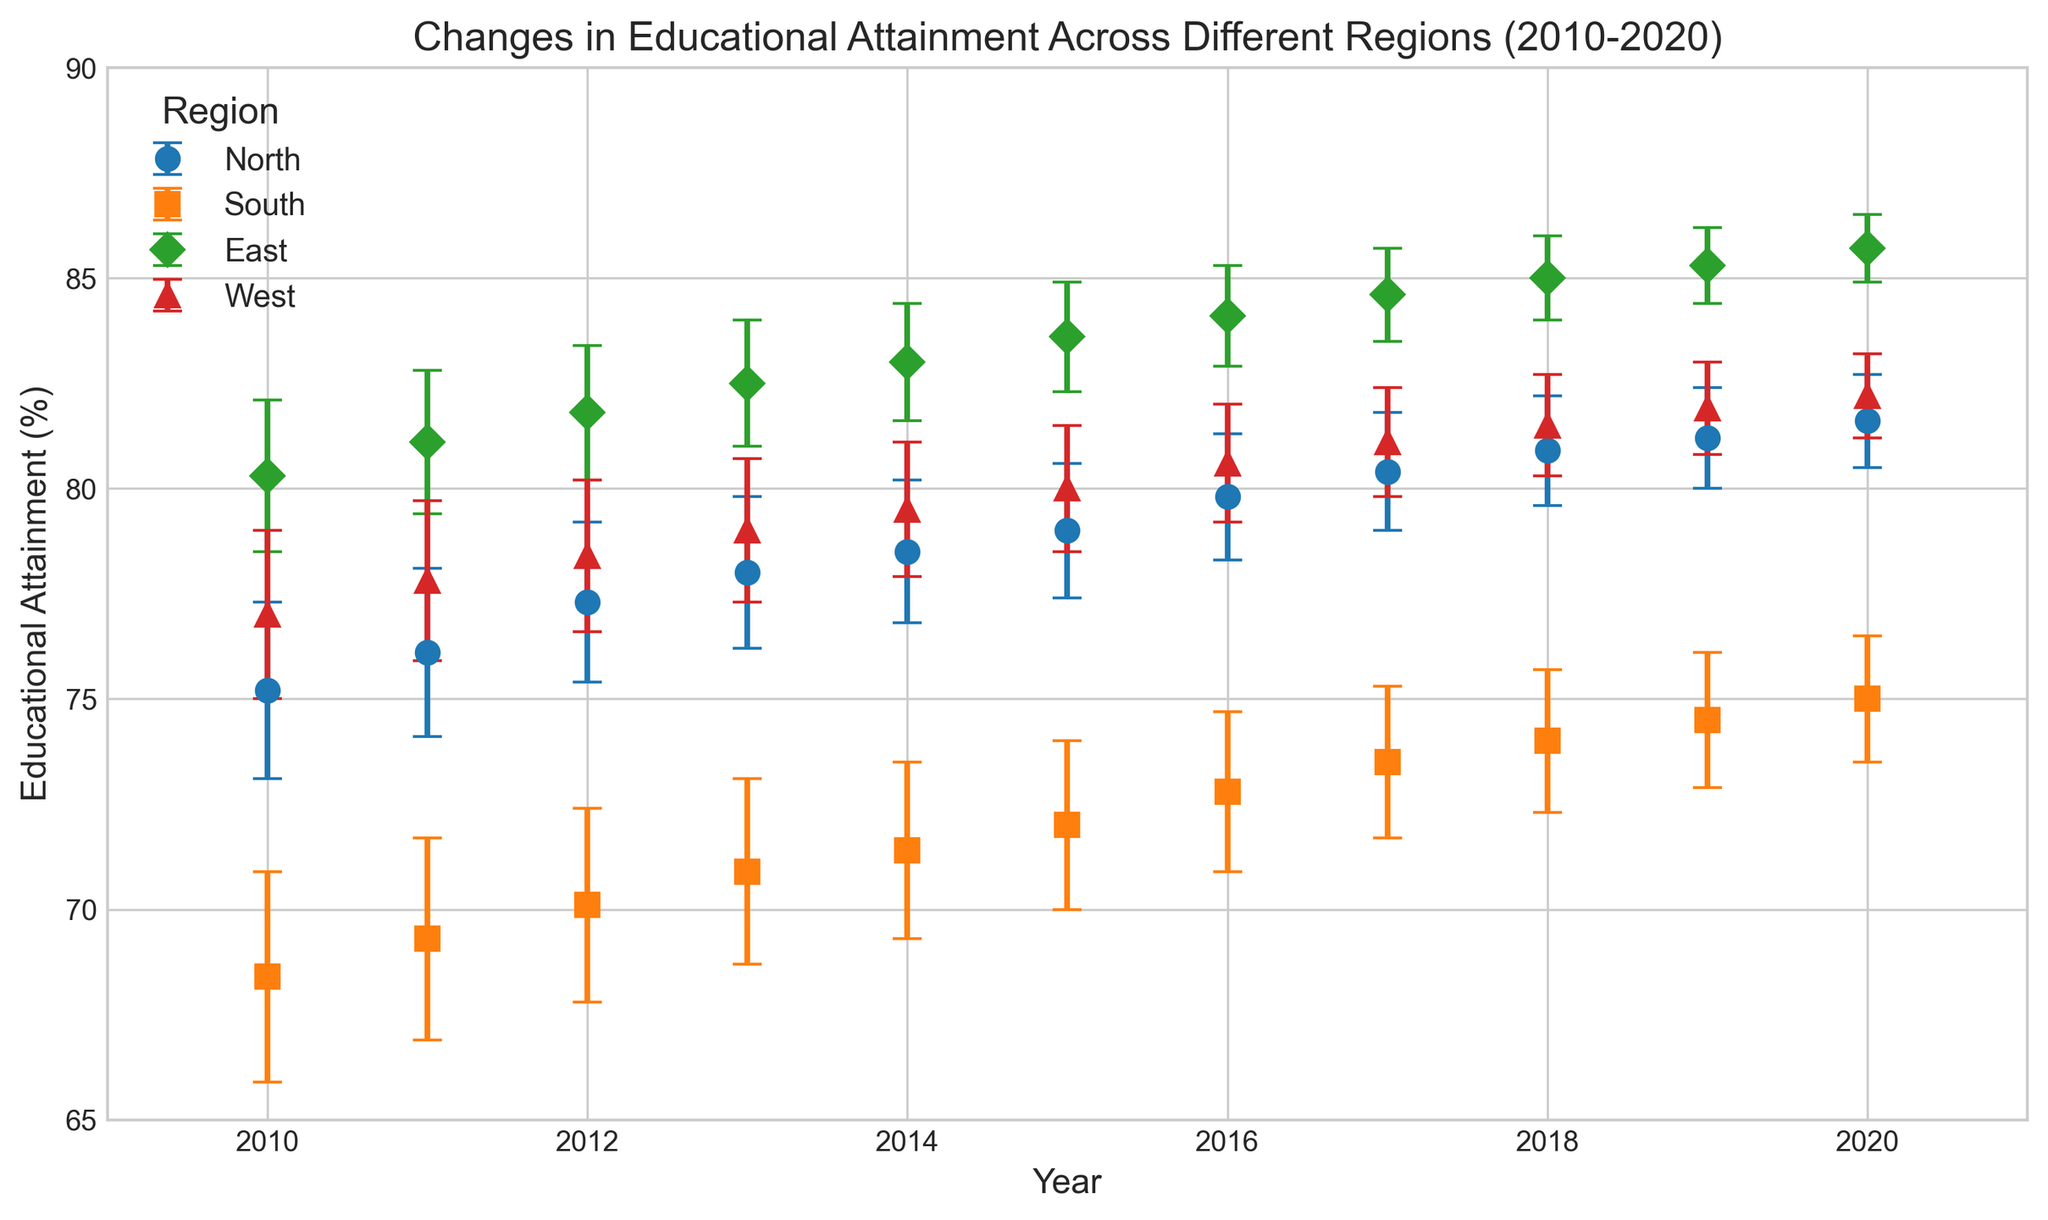Which region had the highest educational attainment in 2020? Looking at the end of the lines in the figure for 2020, the East region has the highest value.
Answer: East What was the difference in educational attainment between the East and South regions in 2015? Identify the points for East and South in 2015, which are 83.6% and 72.0%, respectively. Subtract these values: 83.6 - 72.0 = 11.6
Answer: 11.6 How has the educational attainment gap between the North and South regions changed from 2010 to 2020? Find the values for North and South in 2010: 75.2% and 68.4%, respectively. Calculate the difference: 75.2 - 68.4 = 6.8. For 2020, North is 81.6% and South is 75.0%. Calculate the difference: 81.6 - 75.0 = 6.6. Compare the gaps: 6.8 (2010) vs 6.6 (2020)
Answer: It has slightly decreased Which region had the smallest error margin in 2020? The error margins are represented by the error bars in 2020. The East region has the smallest error bar.
Answer: East Between which consecutive years did the North region see the largest increase in educational attainment? Look at the slope of the line for the North region between each pair of consecutive years. Between 2011 and 2012, the jump is from 76.1% to 77.3%, an increase of 1.2, which is the largest.
Answer: 2011 to 2012 In which year did the West region surpass the 80% educational attainment mark? Identify the point where the West region crosses the 80% line. This occurs between 2014 and 2015.
Answer: 2015 Compare the educational attainment growth rate of the East and West regions from 2010 to 2020. Which had a higher average annual growth rate? Calculate the total increase for East (85.7 - 80.3 = 5.4) and West (82.2 - 77.0 = 5.2). Divide each by the number of years (10): East = 5.4/10 = 0.54, West = 5.2/10 = 0.52
Answer: East Do any regions have overlapping error margins in 2020? Check the error bars for overlap. North (81.6±1.1), South (75.0±1.5), East (85.7±0.8), West (82.2±1.0). There is no overlap.
Answer: No Which region had the most stable educational attainment (smallest changes) over the decade? The East region shows the smallest changes across the years with a steady line, indicating stability.
Answer: East What was the educational attainment of the North region in 2014 relative to the following year's attainment? Compare North's 2014 attainment (78.5%) to 2015 (79.0%). The difference is 79.0 - 78.5 = 0.5 lower.
Answer: 0.5 lower 